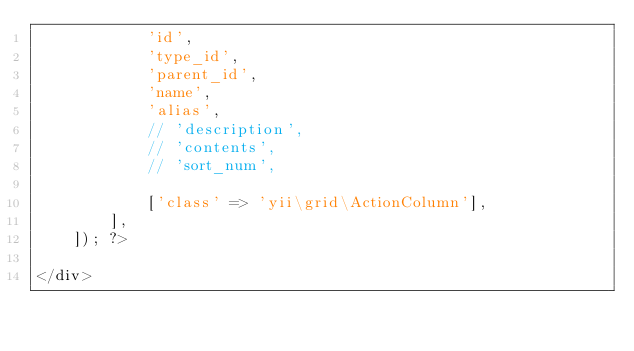Convert code to text. <code><loc_0><loc_0><loc_500><loc_500><_PHP_>            'id',
            'type_id',
            'parent_id',
            'name',
            'alias',
            // 'description',
            // 'contents',
            // 'sort_num',

            ['class' => 'yii\grid\ActionColumn'],
        ],
    ]); ?>

</div>
</code> 